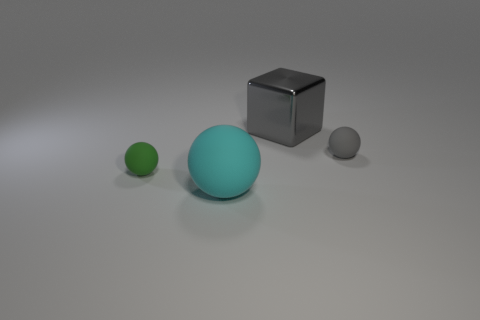Subtract all large cyan rubber balls. How many balls are left? 2 Add 1 tiny gray balls. How many objects exist? 5 Add 3 small red spheres. How many small red spheres exist? 3 Subtract all green spheres. How many spheres are left? 2 Subtract 1 gray blocks. How many objects are left? 3 Subtract all blocks. How many objects are left? 3 Subtract 1 cubes. How many cubes are left? 0 Subtract all blue spheres. Subtract all yellow cylinders. How many spheres are left? 3 Subtract all red blocks. How many yellow spheres are left? 0 Subtract all big gray metallic cubes. Subtract all blue spheres. How many objects are left? 3 